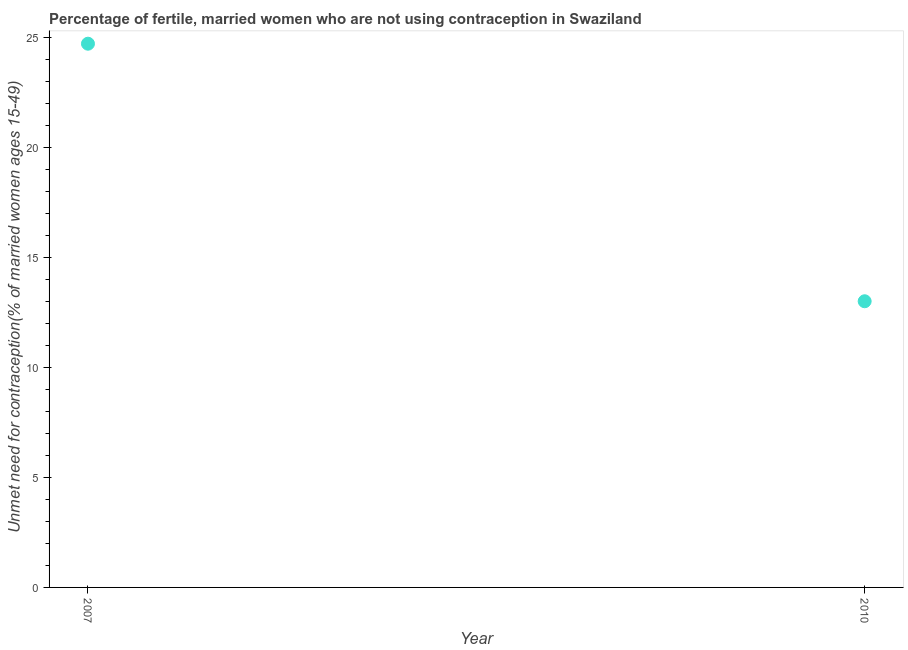What is the number of married women who are not using contraception in 2010?
Your response must be concise. 13. Across all years, what is the maximum number of married women who are not using contraception?
Keep it short and to the point. 24.7. Across all years, what is the minimum number of married women who are not using contraception?
Provide a short and direct response. 13. In which year was the number of married women who are not using contraception maximum?
Give a very brief answer. 2007. What is the sum of the number of married women who are not using contraception?
Keep it short and to the point. 37.7. What is the difference between the number of married women who are not using contraception in 2007 and 2010?
Your answer should be very brief. 11.7. What is the average number of married women who are not using contraception per year?
Your response must be concise. 18.85. What is the median number of married women who are not using contraception?
Provide a short and direct response. 18.85. In how many years, is the number of married women who are not using contraception greater than 3 %?
Provide a succinct answer. 2. Is the number of married women who are not using contraception in 2007 less than that in 2010?
Your answer should be compact. No. In how many years, is the number of married women who are not using contraception greater than the average number of married women who are not using contraception taken over all years?
Your answer should be very brief. 1. Does the number of married women who are not using contraception monotonically increase over the years?
Offer a terse response. No. Are the values on the major ticks of Y-axis written in scientific E-notation?
Provide a succinct answer. No. Does the graph contain grids?
Offer a terse response. No. What is the title of the graph?
Provide a succinct answer. Percentage of fertile, married women who are not using contraception in Swaziland. What is the label or title of the Y-axis?
Give a very brief answer.  Unmet need for contraception(% of married women ages 15-49). What is the  Unmet need for contraception(% of married women ages 15-49) in 2007?
Provide a short and direct response. 24.7. What is the  Unmet need for contraception(% of married women ages 15-49) in 2010?
Ensure brevity in your answer.  13. What is the difference between the  Unmet need for contraception(% of married women ages 15-49) in 2007 and 2010?
Keep it short and to the point. 11.7. What is the ratio of the  Unmet need for contraception(% of married women ages 15-49) in 2007 to that in 2010?
Make the answer very short. 1.9. 